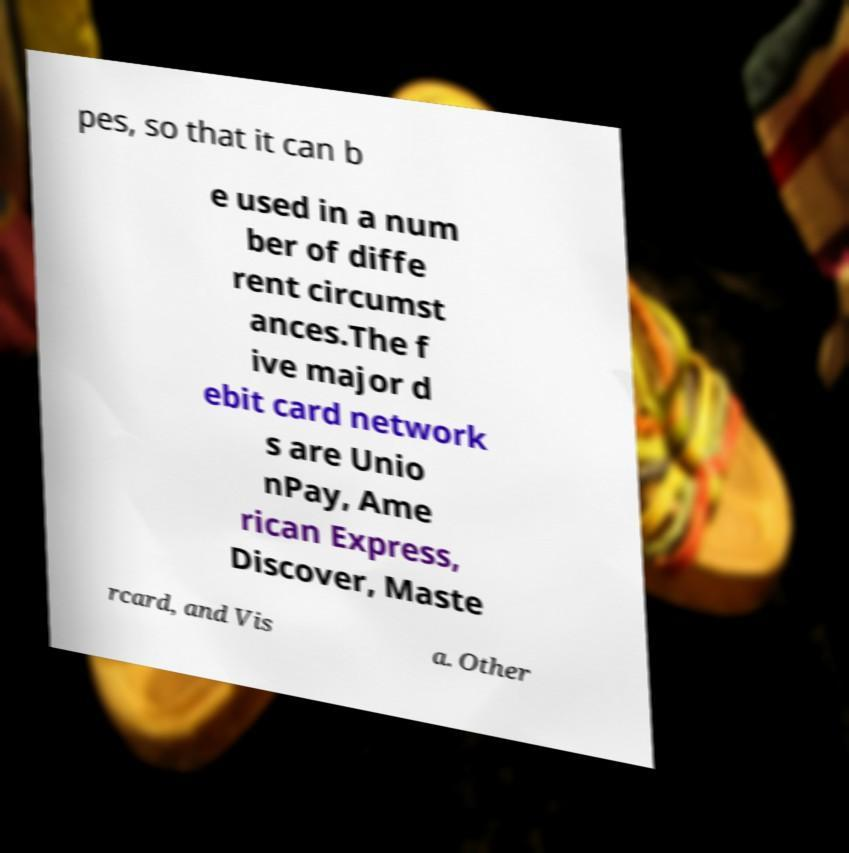What messages or text are displayed in this image? I need them in a readable, typed format. pes, so that it can b e used in a num ber of diffe rent circumst ances.The f ive major d ebit card network s are Unio nPay, Ame rican Express, Discover, Maste rcard, and Vis a. Other 